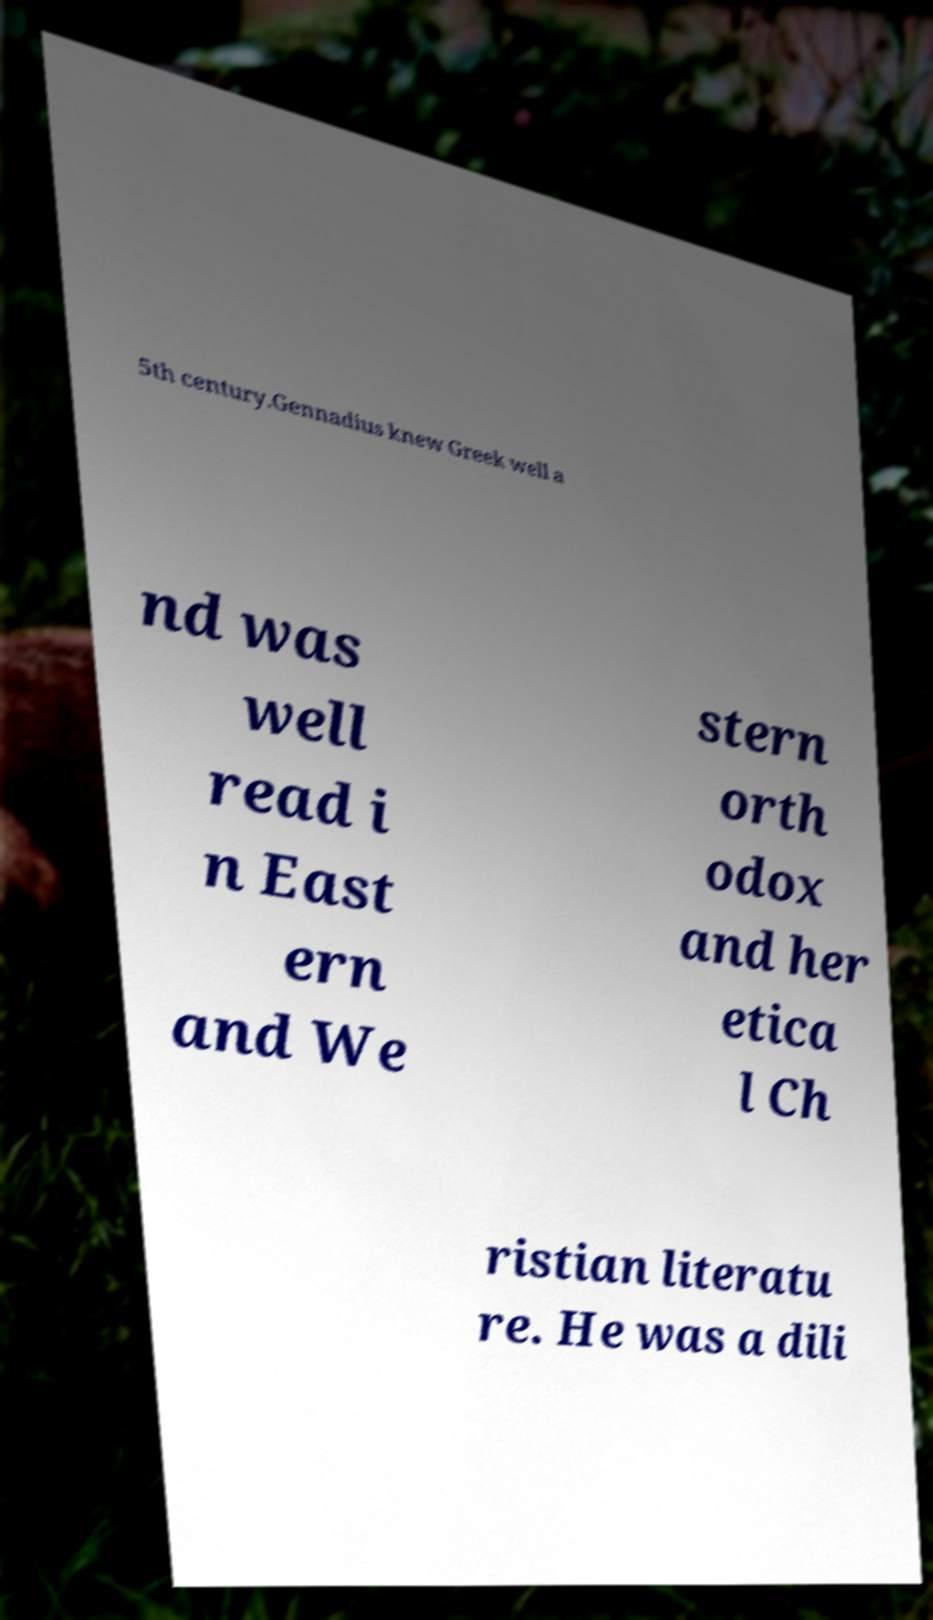Please identify and transcribe the text found in this image. 5th century.Gennadius knew Greek well a nd was well read i n East ern and We stern orth odox and her etica l Ch ristian literatu re. He was a dili 